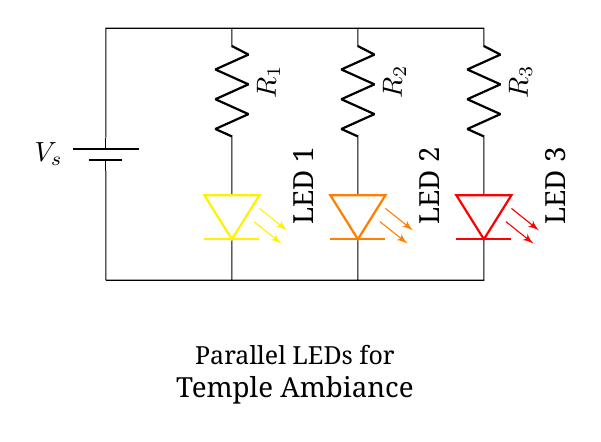What is the type of connection used for the LEDs? The LEDs are connected in parallel, which means that they share the same voltage source while each LED has its own individual path for current to flow.
Answer: Parallel How many LEDs are in this circuit? The circuit diagram shows three distinct LEDs labeled LED 1, LED 2, and LED 3, suggesting that this is the total count of LEDs present.
Answer: Three What color is LED 2? Looking at the diagram, LED 2 is colored orange, as indicated by its representation in the circuit visualization.
Answer: Orange What is the purpose of the resistors in this circuit? Each resistor is used to limit the current flowing through the corresponding LED, protecting them from being damaged by excessive current.
Answer: Current limiting What voltage do all LEDs share? Since all LEDs are in parallel, they all share the same source voltage V_s shown at the top of the circuit, which is the input voltage to the circuit.
Answer: V_s Which LED is connected with the highest resistance? LED 3 is connected with resistor R_3, which has the highest position in the order of circuit element connection, likely indicating that it has the highest resistance among the three.
Answer: R_3 